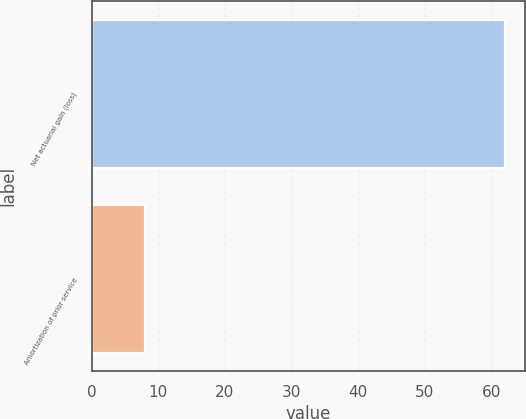<chart> <loc_0><loc_0><loc_500><loc_500><bar_chart><fcel>Net actuarial gain (loss)<fcel>Amortization of prior service<nl><fcel>62<fcel>8<nl></chart> 